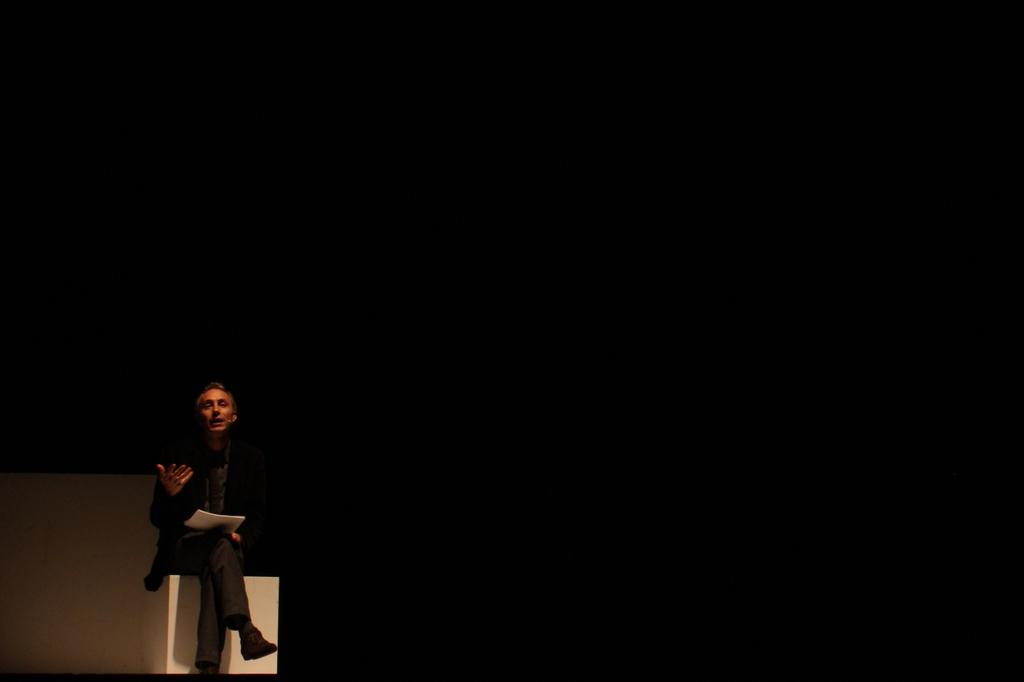What is the person in the image doing? The person is sitting on a bench in the image. What color is the bench the person is sitting on? The bench is white in color. What is the person holding in their hand? The person is holding papers in their hand. What can be seen in the background of the image? The background of the image appears to be black. What type of wave can be seen crashing on the shore in the image? There is no wave or shore present in the image; it features a person sitting on a bench. What type of dress is the person wearing in the image? The provided facts do not mention any dress or clothing worn by the person in the image. 